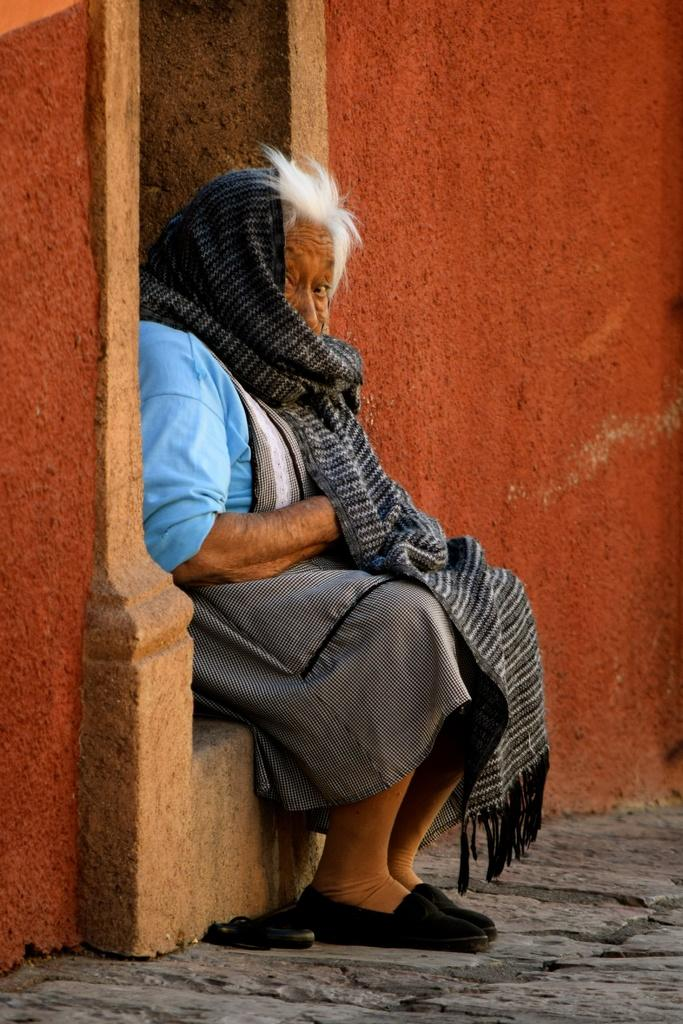What is the lady in the image doing? The lady is sitting in the image. What can be seen behind the lady? There is a wall visible in the image. What is the surface beneath the lady's feet? There is ground visible in the image. What is present on the ground in the image? There are objects present on the ground. Can you see any animals from the zoo in the image? There is no zoo or animals present in the image. What type of car is parked next to the lady in the image? There is no car present in the image. 